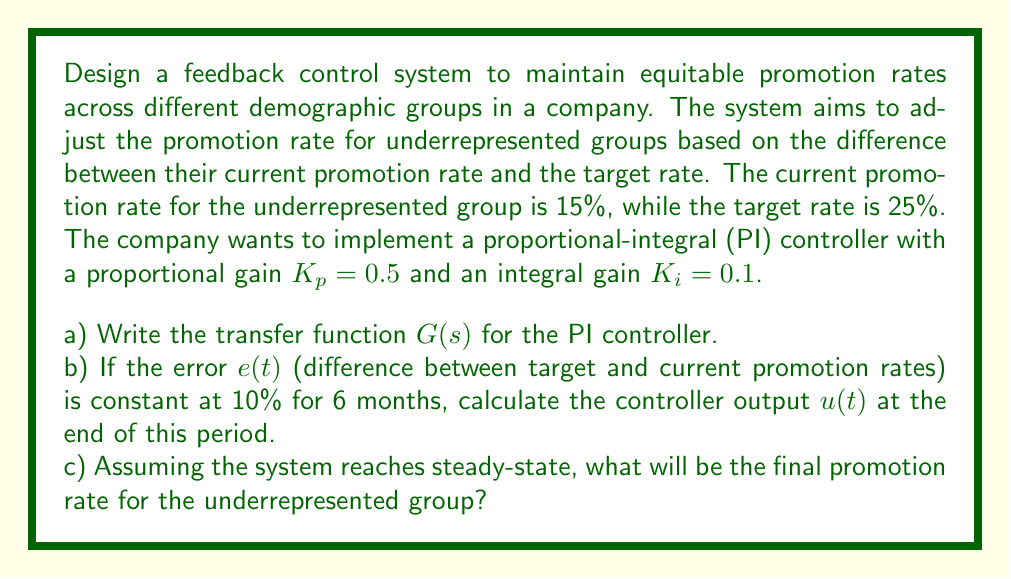Can you solve this math problem? Let's approach this problem step by step:

a) The transfer function for a PI controller is given by:

$$ G(s) = K_p + \frac{K_i}{s} $$

Where $K_p$ is the proportional gain and $K_i$ is the integral gain. Substituting the given values:

$$ G(s) = 0.5 + \frac{0.1}{s} $$

b) To calculate the controller output $u(t)$ after 6 months with a constant error, we need to use the time-domain equation for a PI controller:

$$ u(t) = K_p e(t) + K_i \int_0^t e(\tau) d\tau $$

Where $e(t)$ is the error, which is constant at 10% (or 0.1 in decimal form).

For the proportional term: $K_p e(t) = 0.5 \times 0.1 = 0.05$

For the integral term: $K_i \int_0^t e(\tau) d\tau = 0.1 \times 0.1 \times 6 = 0.06$
(The integral of a constant error over 6 months is simply $0.1 \times 6 = 0.6$)

Therefore, the total controller output after 6 months is:

$$ u(6) = 0.05 + 0.06 = 0.11 $$

c) In steady-state, the error should approach zero, meaning the actual promotion rate should equal the target rate. Therefore, the final promotion rate for the underrepresented group will be 25%.

To verify this mathematically, we can use the concept of steady-state error for a PI controller. For a step input (constant target), a PI controller will eliminate the steady-state error, meaning:

$$ \lim_{t \to \infty} e(t) = 0 $$

This implies that the final output will match the target input, which is 25% in this case.
Answer: a) $G(s) = 0.5 + \frac{0.1}{s}$
b) $u(6) = 0.11$ or 11%
c) Final promotion rate = 25% 